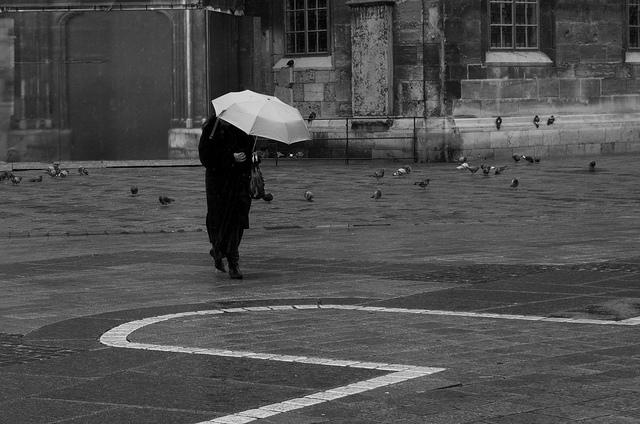What is the person hiding behind? Please explain your reasoning. umbrella. A woman is holding an large item to block rain. 